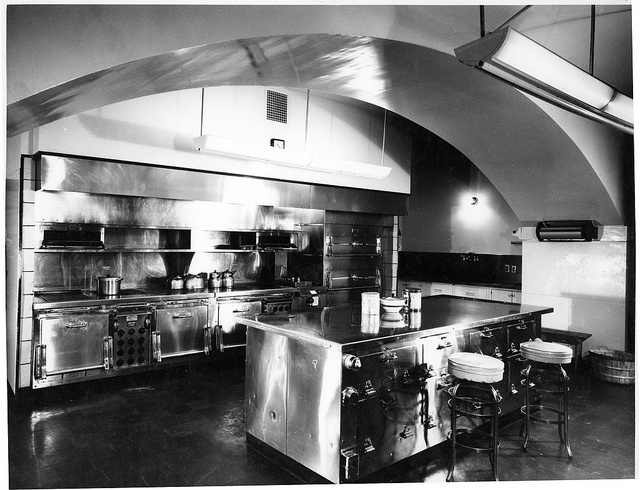Describe the objects in this image and their specific colors. I can see oven in white, black, gray, darkgray, and lightgray tones, chair in white, black, lightgray, gray, and darkgray tones, chair in white, black, gray, lightgray, and darkgray tones, oven in white, gray, black, darkgray, and lightgray tones, and oven in white, black, gray, darkgray, and lightgray tones in this image. 